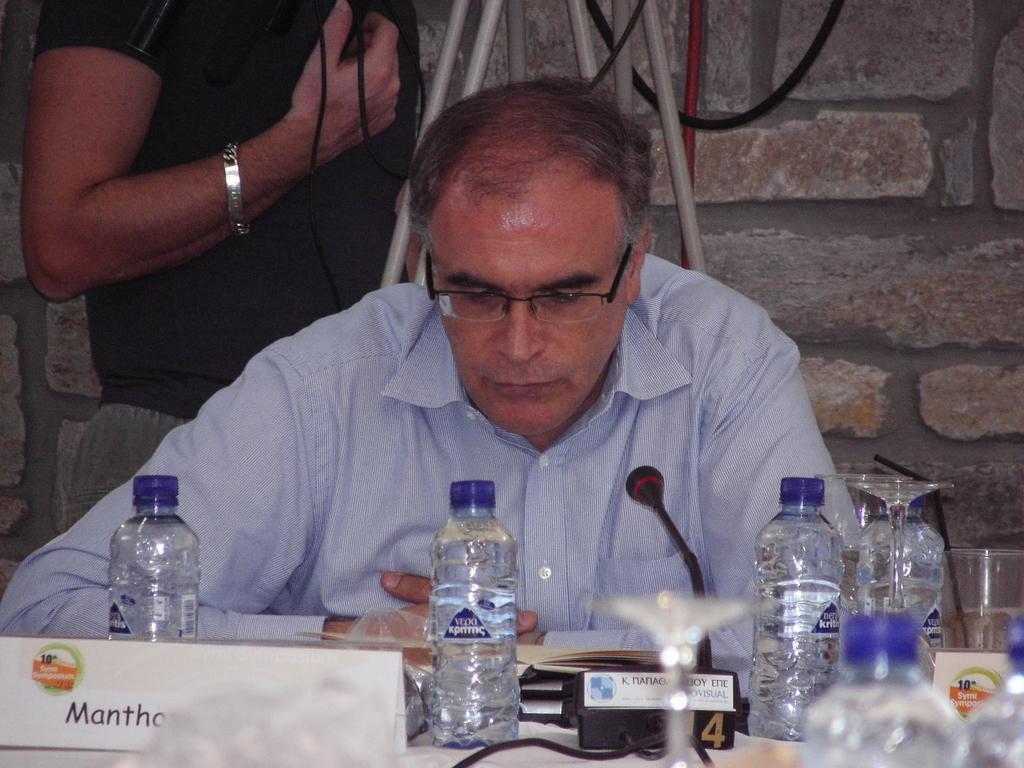In one or two sentences, can you explain what this image depicts? In this picture we can see a man. He has spectacles. This is table. On the table there are bottles and this is mike. On the background there is a wall and these are the cables. 